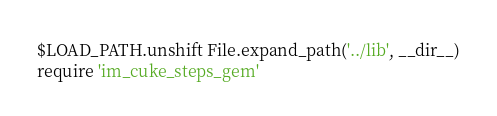Convert code to text. <code><loc_0><loc_0><loc_500><loc_500><_Ruby_>$LOAD_PATH.unshift File.expand_path('../lib', __dir__)
require 'im_cuke_steps_gem'
</code> 